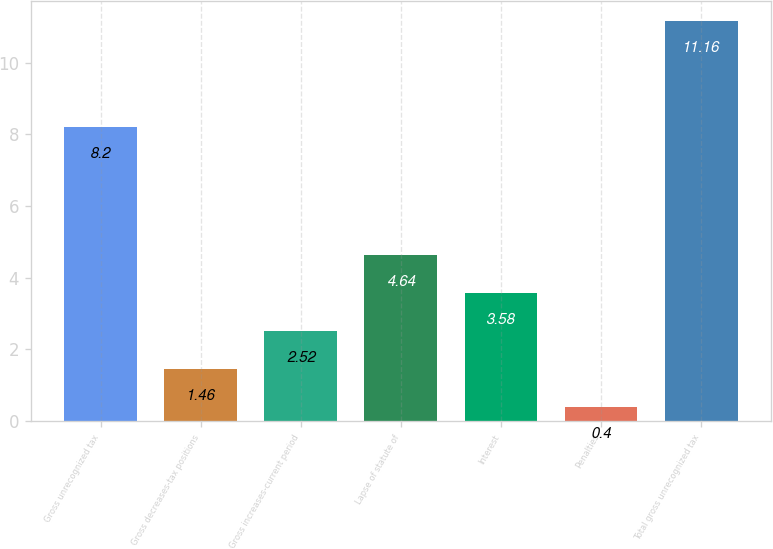Convert chart. <chart><loc_0><loc_0><loc_500><loc_500><bar_chart><fcel>Gross unrecognized tax<fcel>Gross decreases-tax positions<fcel>Gross increases-current period<fcel>Lapse of statute of<fcel>Interest<fcel>Penalties<fcel>Total gross unrecognized tax<nl><fcel>8.2<fcel>1.46<fcel>2.52<fcel>4.64<fcel>3.58<fcel>0.4<fcel>11.16<nl></chart> 